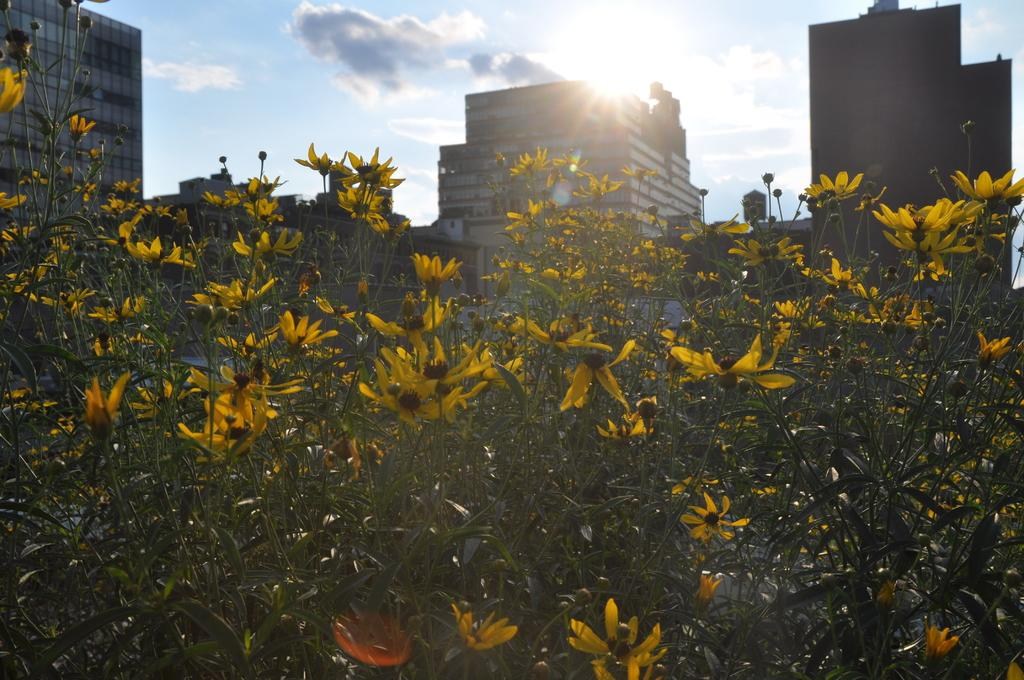What type of plants can be seen in the image? There are plants with flowers in the image. What can be seen in the distance behind the plants? There are buildings in the background of the image. How would you describe the sky in the image? The sky is cloudy in the background of the image. What type of hook can be seen hanging from the plants in the image? There is no hook present in the image; it features plants with flowers and a cloudy sky in the background. 